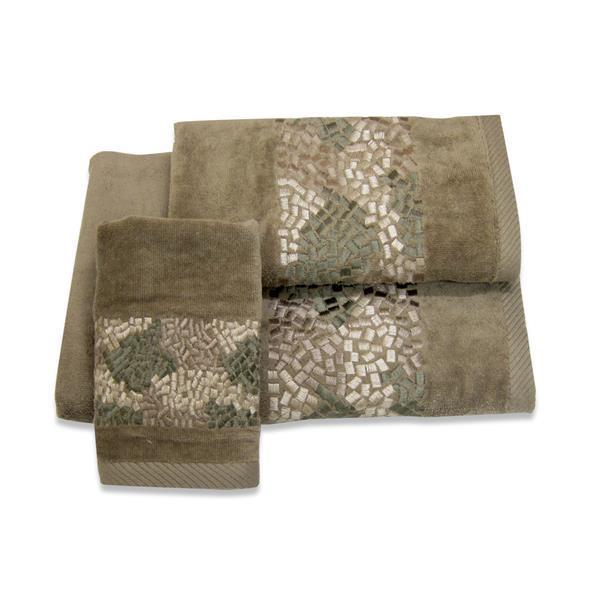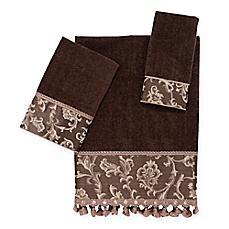The first image is the image on the left, the second image is the image on the right. Evaluate the accuracy of this statement regarding the images: "All towels are edged with braid trim or all towels are edged with ball trim.". Is it true? Answer yes or no. No. 